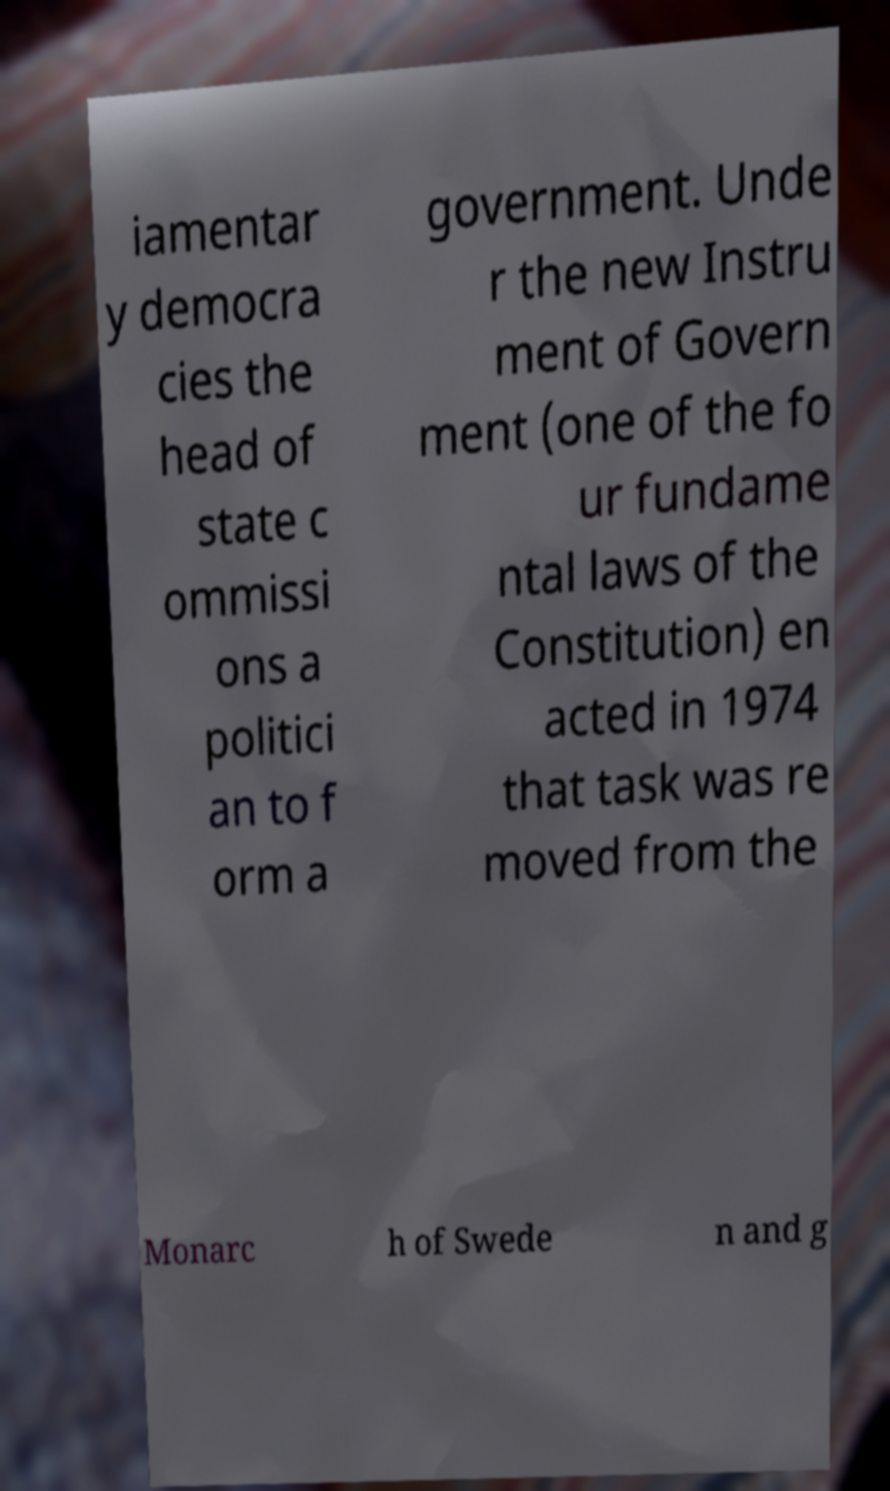Can you read and provide the text displayed in the image?This photo seems to have some interesting text. Can you extract and type it out for me? iamentar y democra cies the head of state c ommissi ons a politici an to f orm a government. Unde r the new Instru ment of Govern ment (one of the fo ur fundame ntal laws of the Constitution) en acted in 1974 that task was re moved from the Monarc h of Swede n and g 